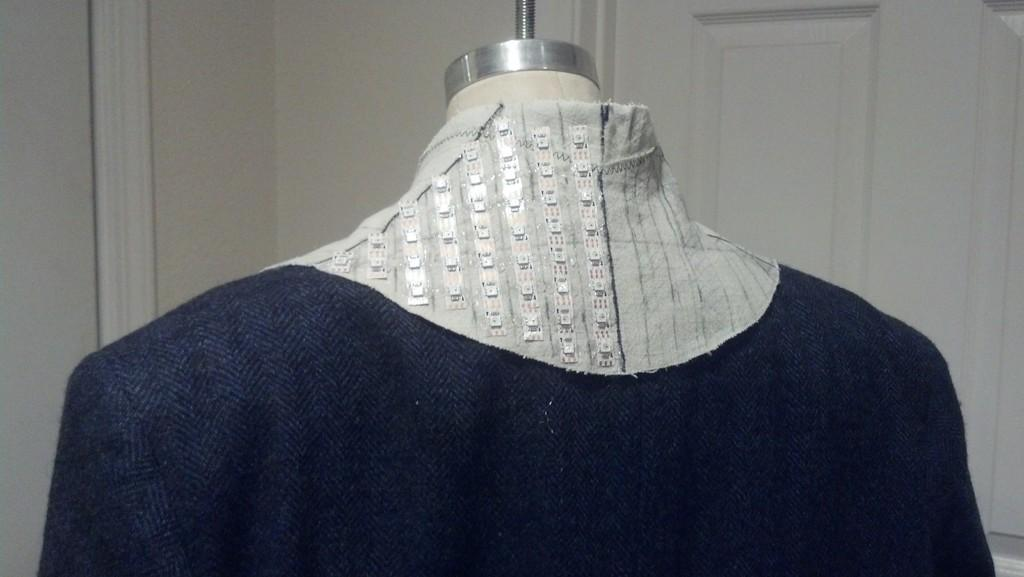What is on display in the image? There is a dress on a mannequin in the image. What architectural feature can be seen in the image? There is a door in the image. What type of structure is visible in the image? There is a wall in the image. What type of boat is docked near the wall in the image? There is no boat present in the image; it only features a dress on a mannequin, a door, and a wall. 